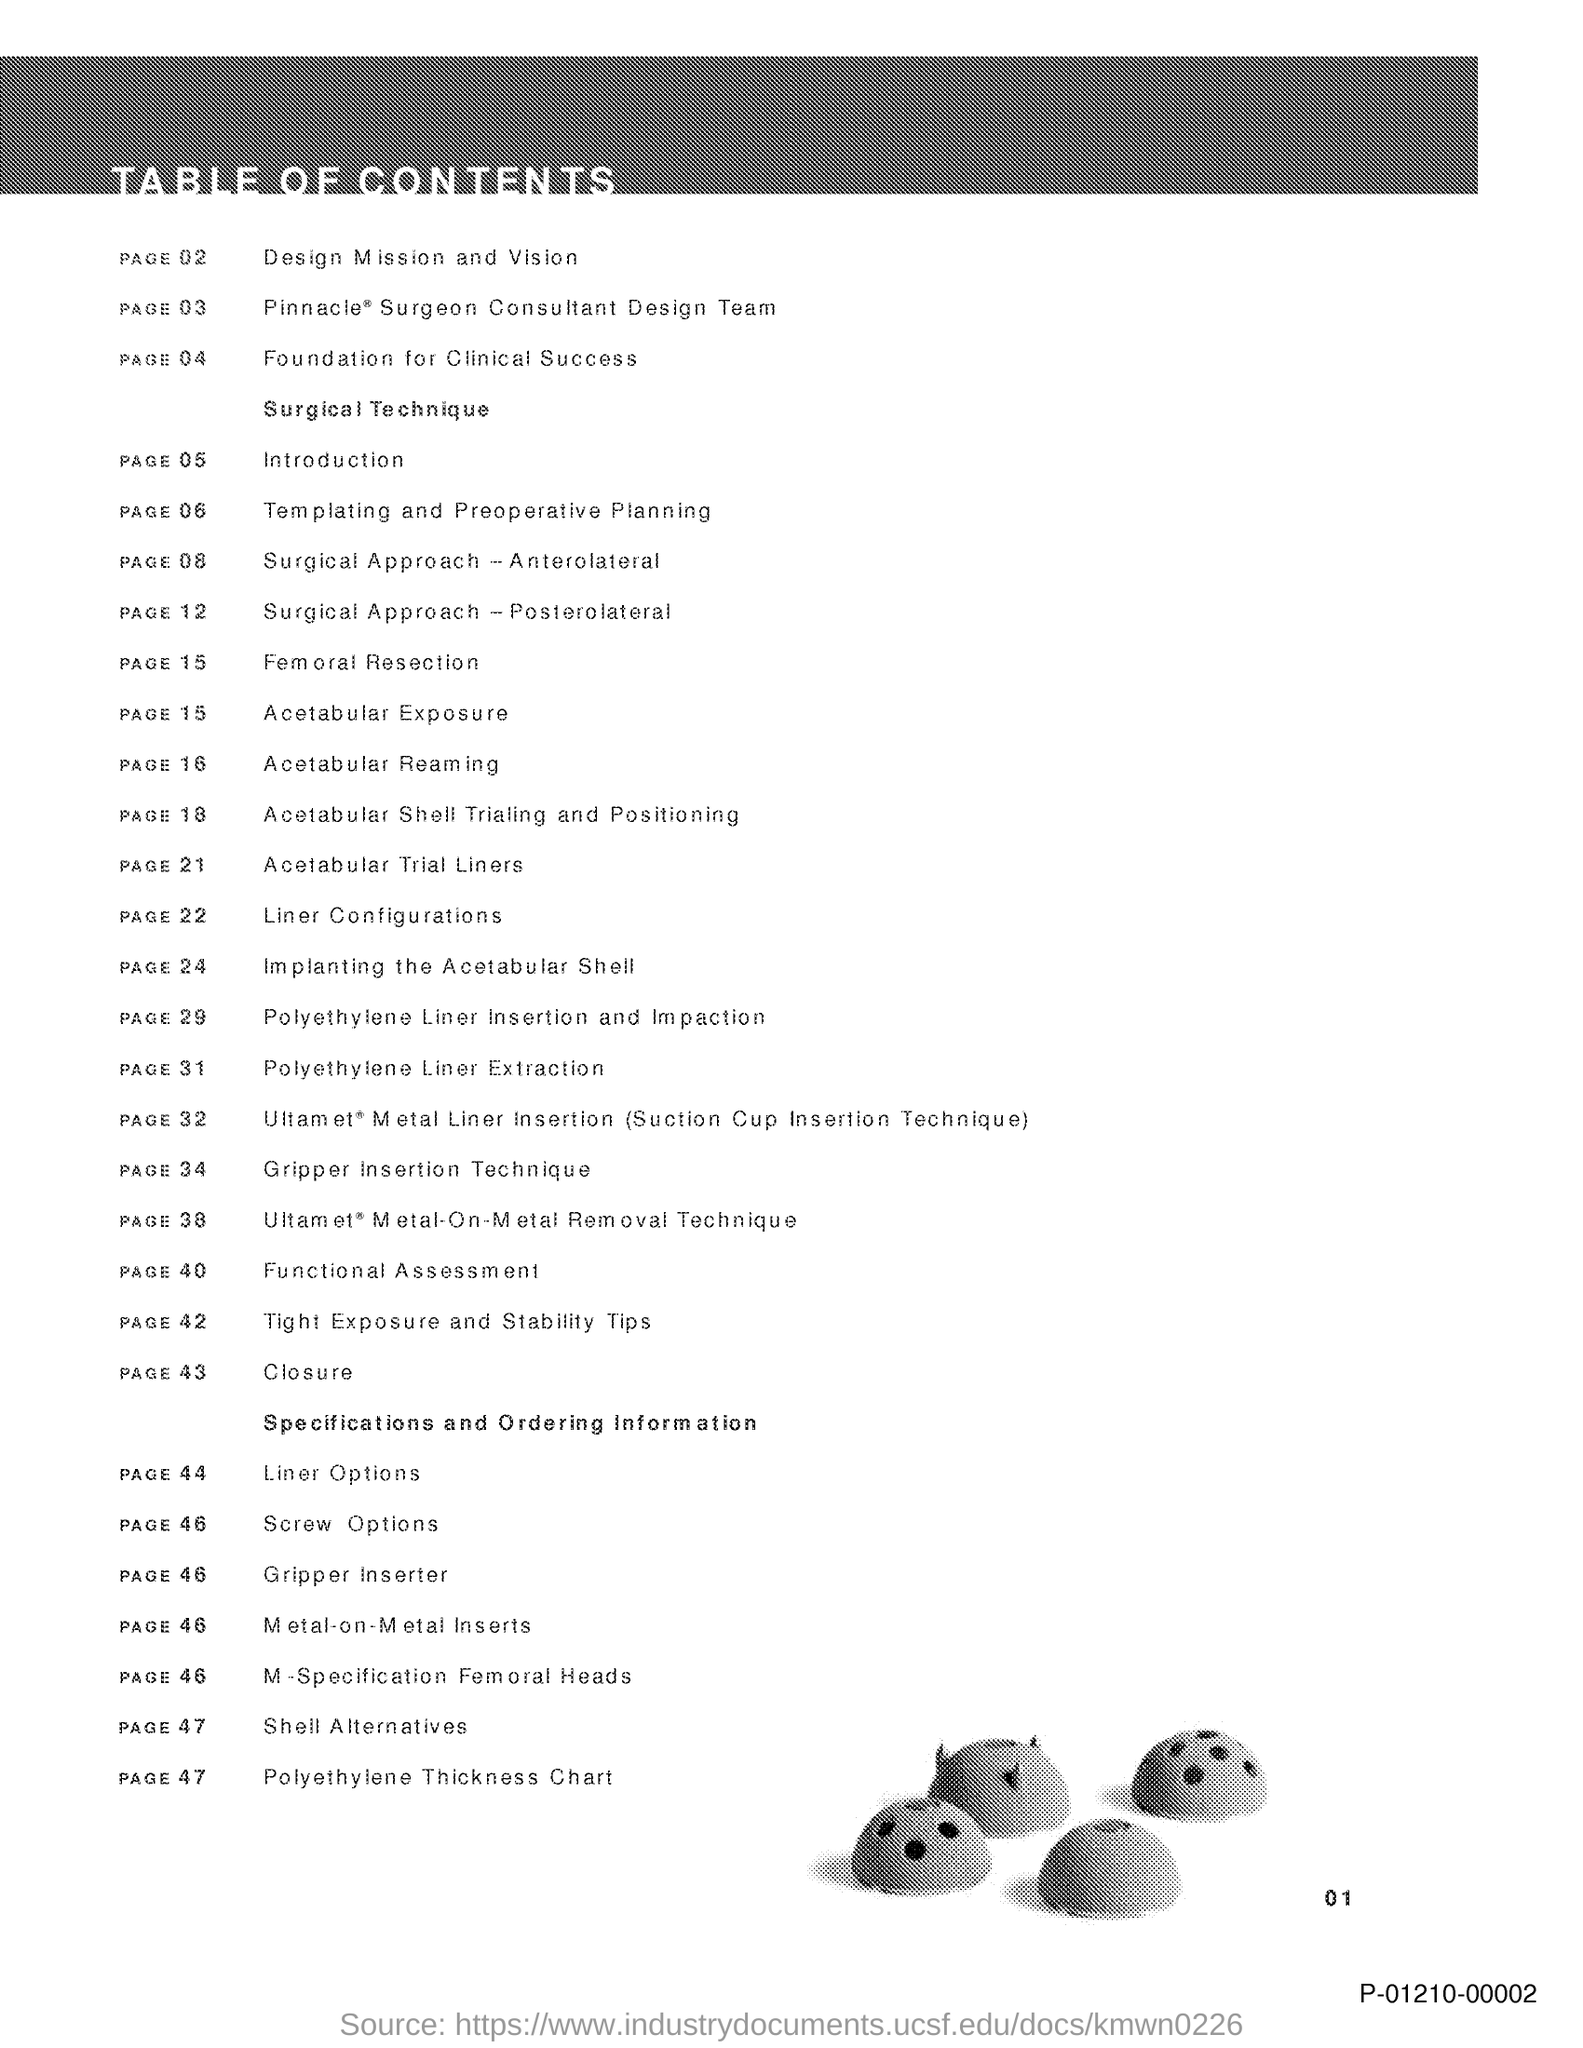Identify some key points in this picture. The introduction can be found on page 05. The linear options can be found on page 44. The document in question is referred to as "Title of the Document." Additionally, it contains a Table of Contents, which provides an organized structure for the content contained within. 